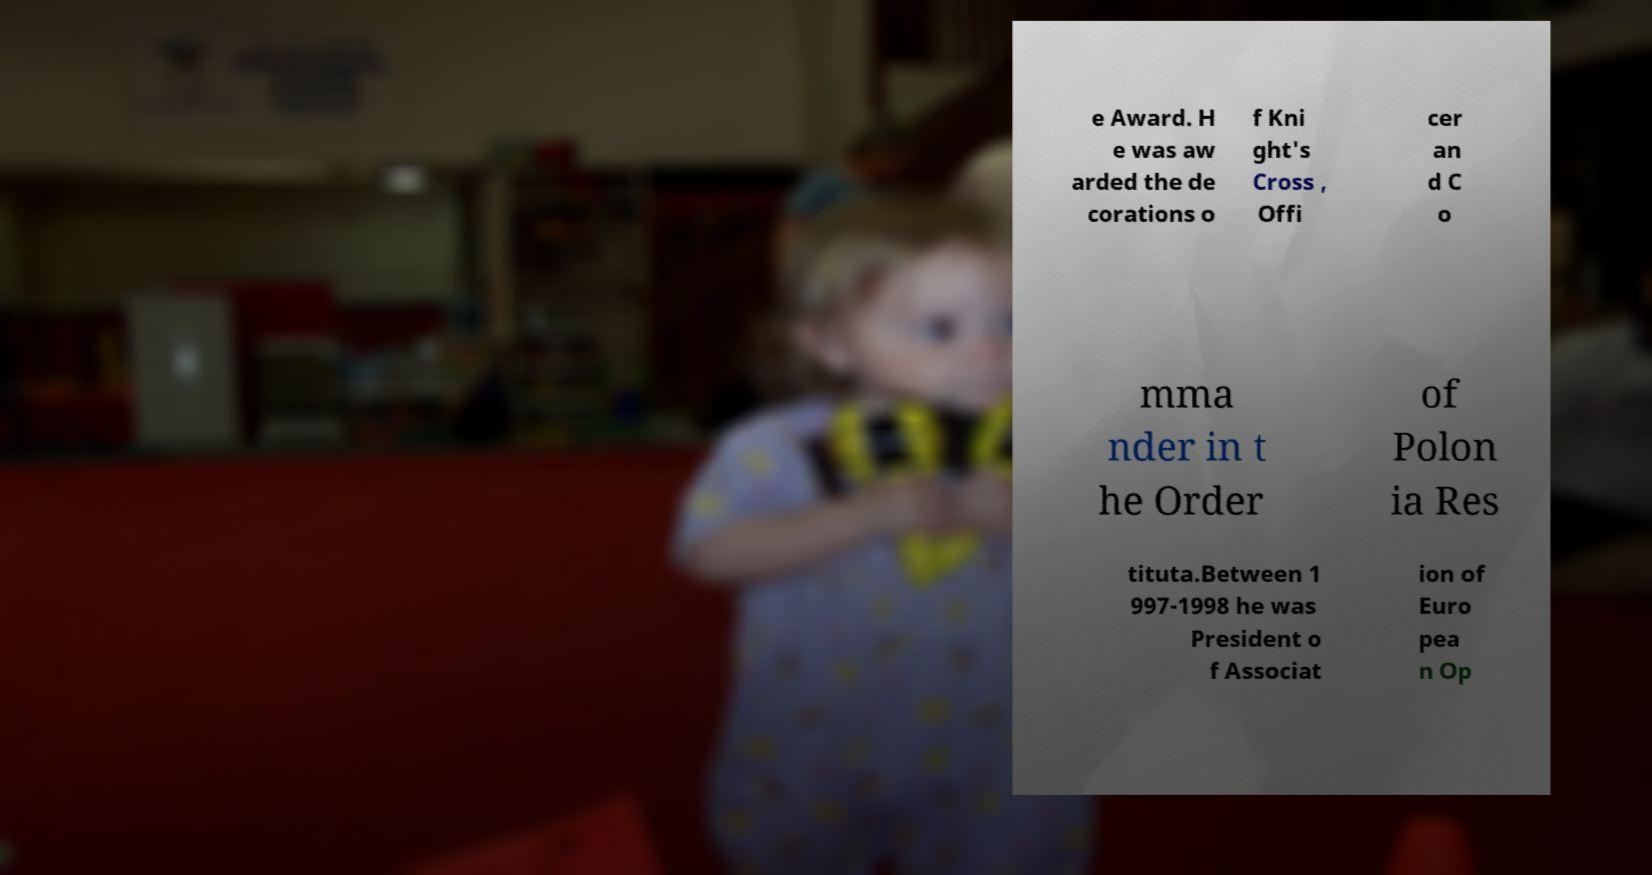What messages or text are displayed in this image? I need them in a readable, typed format. e Award. H e was aw arded the de corations o f Kni ght's Cross , Offi cer an d C o mma nder in t he Order of Polon ia Res tituta.Between 1 997-1998 he was President o f Associat ion of Euro pea n Op 